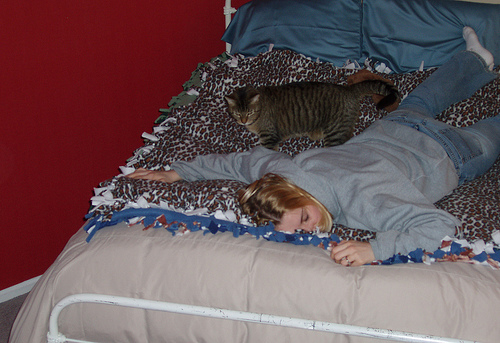<image>
Is there a cat above the woman? No. The cat is not positioned above the woman. The vertical arrangement shows a different relationship. 